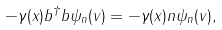<formula> <loc_0><loc_0><loc_500><loc_500>- \gamma ( x ) b ^ { \dagger } b \psi _ { n } ( v ) = - \gamma ( x ) n \psi _ { n } ( v ) ,</formula> 